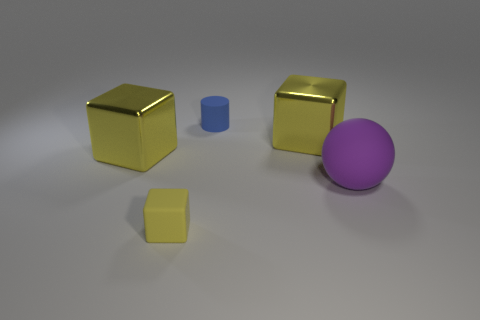Add 4 balls. How many objects exist? 9 Subtract all blocks. How many objects are left? 2 Add 3 tiny blue rubber cylinders. How many tiny blue rubber cylinders exist? 4 Subtract 0 red cylinders. How many objects are left? 5 Subtract all big yellow blocks. Subtract all purple spheres. How many objects are left? 2 Add 4 big balls. How many big balls are left? 5 